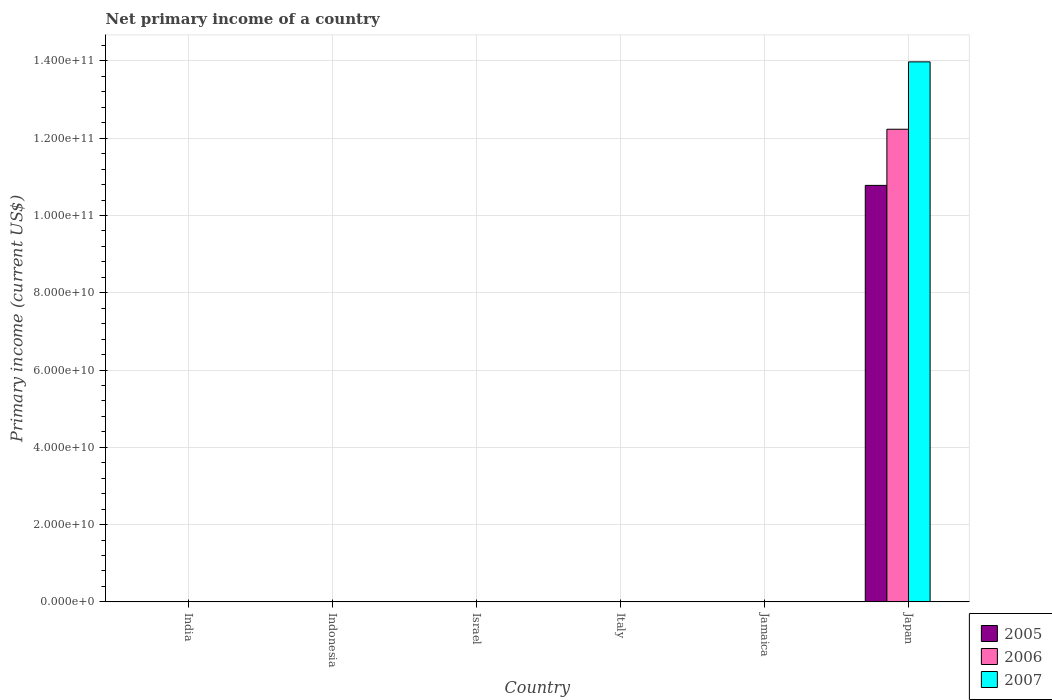Are the number of bars per tick equal to the number of legend labels?
Keep it short and to the point. No. How many bars are there on the 3rd tick from the left?
Provide a short and direct response. 0. How many bars are there on the 6th tick from the right?
Offer a terse response. 0. What is the label of the 4th group of bars from the left?
Offer a very short reply. Italy. Across all countries, what is the maximum primary income in 2005?
Ensure brevity in your answer.  1.08e+11. In which country was the primary income in 2005 maximum?
Your answer should be compact. Japan. What is the total primary income in 2007 in the graph?
Your response must be concise. 1.40e+11. What is the difference between the primary income in 2006 in Jamaica and the primary income in 2005 in Japan?
Ensure brevity in your answer.  -1.08e+11. What is the average primary income in 2007 per country?
Offer a very short reply. 2.33e+1. What is the difference between the highest and the lowest primary income in 2007?
Your response must be concise. 1.40e+11. In how many countries, is the primary income in 2006 greater than the average primary income in 2006 taken over all countries?
Offer a terse response. 1. Is it the case that in every country, the sum of the primary income in 2007 and primary income in 2006 is greater than the primary income in 2005?
Your answer should be very brief. No. Are all the bars in the graph horizontal?
Keep it short and to the point. No. How many countries are there in the graph?
Provide a short and direct response. 6. Are the values on the major ticks of Y-axis written in scientific E-notation?
Offer a very short reply. Yes. Does the graph contain any zero values?
Provide a short and direct response. Yes. Does the graph contain grids?
Your answer should be compact. Yes. Where does the legend appear in the graph?
Keep it short and to the point. Bottom right. How many legend labels are there?
Provide a succinct answer. 3. What is the title of the graph?
Provide a short and direct response. Net primary income of a country. Does "2003" appear as one of the legend labels in the graph?
Offer a terse response. No. What is the label or title of the X-axis?
Ensure brevity in your answer.  Country. What is the label or title of the Y-axis?
Your answer should be compact. Primary income (current US$). What is the Primary income (current US$) of 2005 in India?
Your response must be concise. 0. What is the Primary income (current US$) of 2007 in India?
Ensure brevity in your answer.  0. What is the Primary income (current US$) of 2005 in Indonesia?
Your answer should be compact. 0. What is the Primary income (current US$) in 2005 in Israel?
Keep it short and to the point. 0. What is the Primary income (current US$) of 2006 in Israel?
Make the answer very short. 0. What is the Primary income (current US$) of 2007 in Israel?
Your answer should be compact. 0. What is the Primary income (current US$) of 2005 in Italy?
Provide a succinct answer. 0. What is the Primary income (current US$) in 2006 in Italy?
Offer a terse response. 0. What is the Primary income (current US$) of 2005 in Jamaica?
Give a very brief answer. 0. What is the Primary income (current US$) of 2006 in Jamaica?
Provide a short and direct response. 0. What is the Primary income (current US$) of 2005 in Japan?
Provide a short and direct response. 1.08e+11. What is the Primary income (current US$) of 2006 in Japan?
Provide a short and direct response. 1.22e+11. What is the Primary income (current US$) in 2007 in Japan?
Your answer should be very brief. 1.40e+11. Across all countries, what is the maximum Primary income (current US$) of 2005?
Offer a very short reply. 1.08e+11. Across all countries, what is the maximum Primary income (current US$) in 2006?
Give a very brief answer. 1.22e+11. Across all countries, what is the maximum Primary income (current US$) in 2007?
Your answer should be very brief. 1.40e+11. Across all countries, what is the minimum Primary income (current US$) in 2005?
Your answer should be very brief. 0. Across all countries, what is the minimum Primary income (current US$) of 2006?
Give a very brief answer. 0. What is the total Primary income (current US$) of 2005 in the graph?
Your response must be concise. 1.08e+11. What is the total Primary income (current US$) in 2006 in the graph?
Offer a terse response. 1.22e+11. What is the total Primary income (current US$) of 2007 in the graph?
Make the answer very short. 1.40e+11. What is the average Primary income (current US$) of 2005 per country?
Keep it short and to the point. 1.80e+1. What is the average Primary income (current US$) of 2006 per country?
Provide a short and direct response. 2.04e+1. What is the average Primary income (current US$) of 2007 per country?
Ensure brevity in your answer.  2.33e+1. What is the difference between the Primary income (current US$) of 2005 and Primary income (current US$) of 2006 in Japan?
Your answer should be very brief. -1.45e+1. What is the difference between the Primary income (current US$) of 2005 and Primary income (current US$) of 2007 in Japan?
Offer a very short reply. -3.20e+1. What is the difference between the Primary income (current US$) of 2006 and Primary income (current US$) of 2007 in Japan?
Ensure brevity in your answer.  -1.74e+1. What is the difference between the highest and the lowest Primary income (current US$) in 2005?
Provide a short and direct response. 1.08e+11. What is the difference between the highest and the lowest Primary income (current US$) of 2006?
Provide a short and direct response. 1.22e+11. What is the difference between the highest and the lowest Primary income (current US$) of 2007?
Provide a short and direct response. 1.40e+11. 